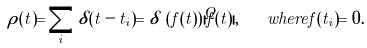<formula> <loc_0><loc_0><loc_500><loc_500>\rho ( t ) = \sum _ { i } \delta ( t - t _ { i } ) = \delta \, \left ( f ( t ) \right ) | \dot { f } ( t ) | , \quad w h e r e f ( t _ { i } ) = 0 .</formula> 